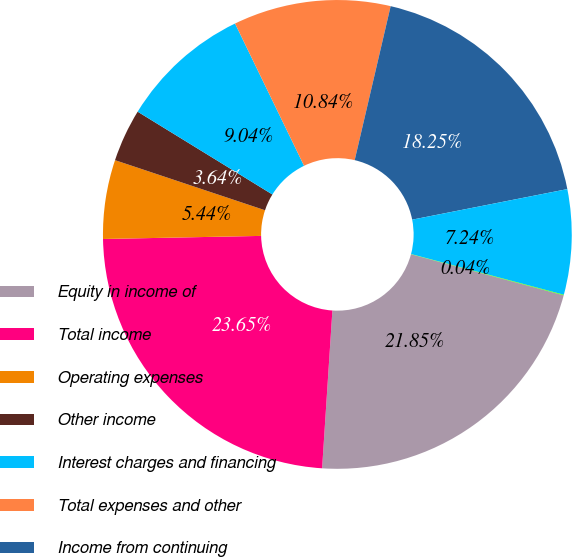Convert chart to OTSL. <chart><loc_0><loc_0><loc_500><loc_500><pie_chart><fcel>Equity in income of<fcel>Total income<fcel>Operating expenses<fcel>Other income<fcel>Interest charges and financing<fcel>Total expenses and other<fcel>Income from continuing<fcel>Income tax benefit<fcel>Income (loss) from<nl><fcel>21.85%<fcel>23.65%<fcel>5.44%<fcel>3.64%<fcel>9.04%<fcel>10.84%<fcel>18.25%<fcel>7.24%<fcel>0.04%<nl></chart> 